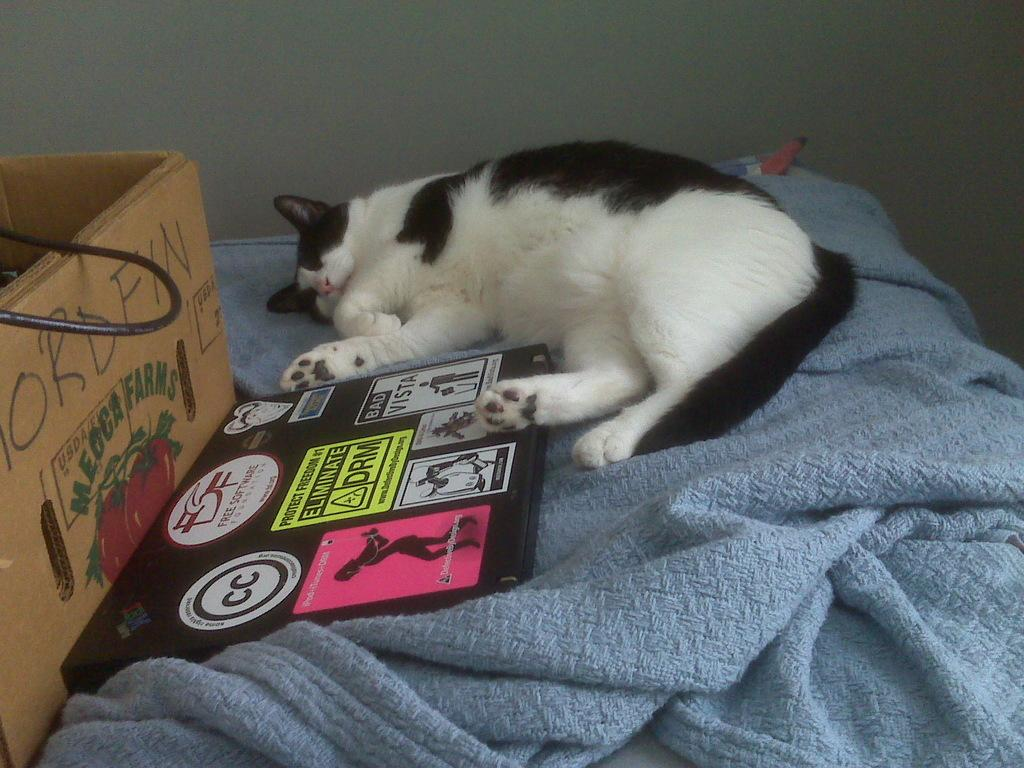<image>
Write a terse but informative summary of the picture. a cat laying next to a book with the word DRM in the middle 